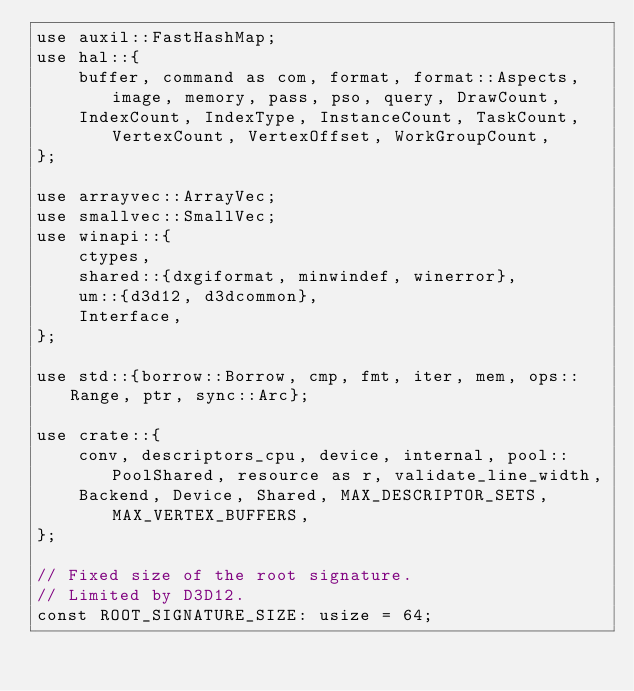<code> <loc_0><loc_0><loc_500><loc_500><_Rust_>use auxil::FastHashMap;
use hal::{
    buffer, command as com, format, format::Aspects, image, memory, pass, pso, query, DrawCount,
    IndexCount, IndexType, InstanceCount, TaskCount, VertexCount, VertexOffset, WorkGroupCount,
};

use arrayvec::ArrayVec;
use smallvec::SmallVec;
use winapi::{
    ctypes,
    shared::{dxgiformat, minwindef, winerror},
    um::{d3d12, d3dcommon},
    Interface,
};

use std::{borrow::Borrow, cmp, fmt, iter, mem, ops::Range, ptr, sync::Arc};

use crate::{
    conv, descriptors_cpu, device, internal, pool::PoolShared, resource as r, validate_line_width,
    Backend, Device, Shared, MAX_DESCRIPTOR_SETS, MAX_VERTEX_BUFFERS,
};

// Fixed size of the root signature.
// Limited by D3D12.
const ROOT_SIGNATURE_SIZE: usize = 64;
</code> 